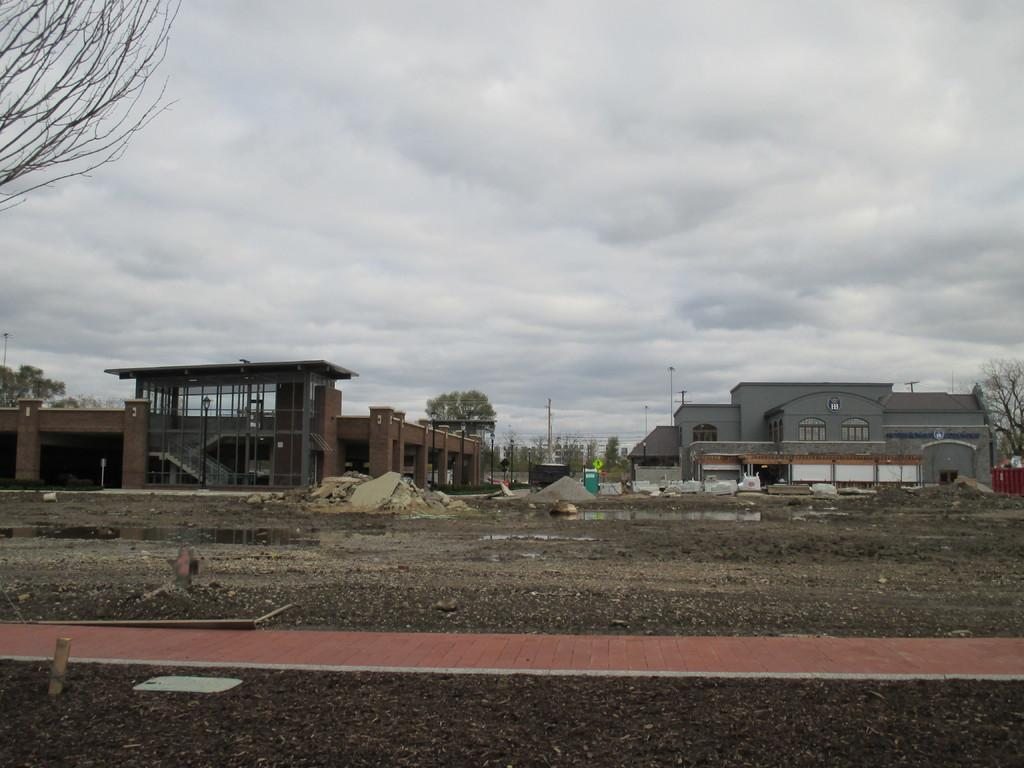What type of terrain is visible in the image? There is sand and muddy water visible in the image. What kind of infrastructure can be seen in the image? There is a path, buildings, wires, poles, and light poles in the image. What type of vegetation is present in the image? There are trees in the image. What is the condition of the sky in the background? The sky in the background is cloudy. How much does the taste of the sand contribute to the overall flavor of the muddy water in the image? There is no indication of taste in the image, as it is a visual representation and does not convey any sensory information. 